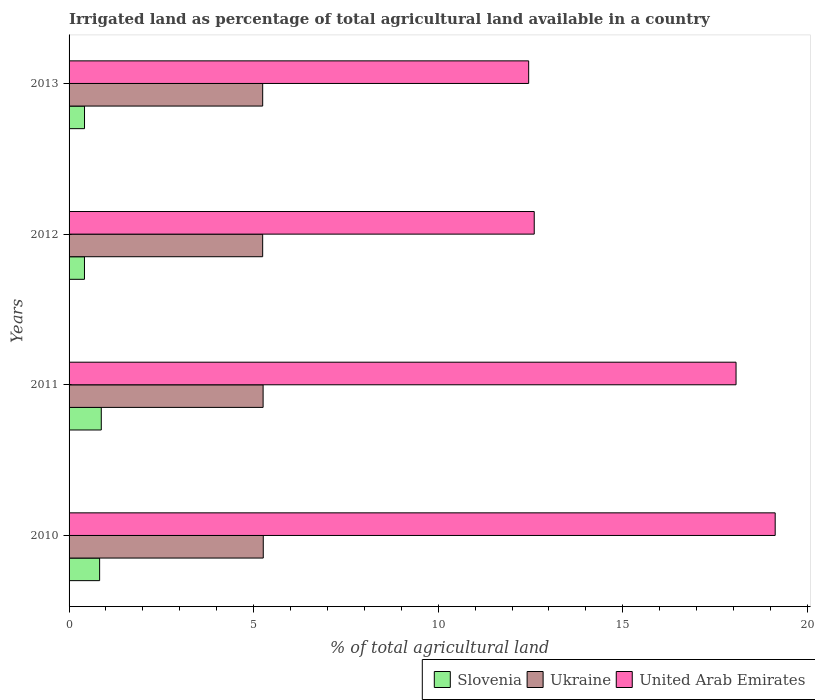How many groups of bars are there?
Keep it short and to the point. 4. Are the number of bars per tick equal to the number of legend labels?
Make the answer very short. Yes. Are the number of bars on each tick of the Y-axis equal?
Offer a terse response. Yes. What is the percentage of irrigated land in Ukraine in 2013?
Ensure brevity in your answer.  5.25. Across all years, what is the maximum percentage of irrigated land in United Arab Emirates?
Give a very brief answer. 19.13. Across all years, what is the minimum percentage of irrigated land in United Arab Emirates?
Your response must be concise. 12.45. In which year was the percentage of irrigated land in Slovenia maximum?
Provide a succinct answer. 2011. In which year was the percentage of irrigated land in Ukraine minimum?
Your answer should be very brief. 2012. What is the total percentage of irrigated land in United Arab Emirates in the graph?
Your response must be concise. 62.25. What is the difference between the percentage of irrigated land in Ukraine in 2010 and that in 2011?
Your response must be concise. 0. What is the difference between the percentage of irrigated land in United Arab Emirates in 2010 and the percentage of irrigated land in Slovenia in 2011?
Your answer should be very brief. 18.26. What is the average percentage of irrigated land in United Arab Emirates per year?
Your response must be concise. 15.56. In the year 2012, what is the difference between the percentage of irrigated land in United Arab Emirates and percentage of irrigated land in Ukraine?
Offer a terse response. 7.36. In how many years, is the percentage of irrigated land in Slovenia greater than 9 %?
Your answer should be very brief. 0. What is the ratio of the percentage of irrigated land in Ukraine in 2010 to that in 2013?
Offer a terse response. 1. Is the percentage of irrigated land in Slovenia in 2012 less than that in 2013?
Keep it short and to the point. Yes. Is the difference between the percentage of irrigated land in United Arab Emirates in 2010 and 2011 greater than the difference between the percentage of irrigated land in Ukraine in 2010 and 2011?
Your response must be concise. Yes. What is the difference between the highest and the second highest percentage of irrigated land in United Arab Emirates?
Provide a short and direct response. 1.06. What is the difference between the highest and the lowest percentage of irrigated land in United Arab Emirates?
Offer a terse response. 6.68. What does the 3rd bar from the top in 2013 represents?
Your response must be concise. Slovenia. What does the 2nd bar from the bottom in 2013 represents?
Offer a terse response. Ukraine. Is it the case that in every year, the sum of the percentage of irrigated land in United Arab Emirates and percentage of irrigated land in Ukraine is greater than the percentage of irrigated land in Slovenia?
Your answer should be very brief. Yes. How many bars are there?
Provide a succinct answer. 12. Are all the bars in the graph horizontal?
Give a very brief answer. Yes. How many years are there in the graph?
Offer a very short reply. 4. Does the graph contain any zero values?
Offer a terse response. No. How are the legend labels stacked?
Offer a terse response. Horizontal. What is the title of the graph?
Your answer should be compact. Irrigated land as percentage of total agricultural land available in a country. Does "Bosnia and Herzegovina" appear as one of the legend labels in the graph?
Keep it short and to the point. No. What is the label or title of the X-axis?
Make the answer very short. % of total agricultural land. What is the % of total agricultural land in Slovenia in 2010?
Offer a very short reply. 0.83. What is the % of total agricultural land in Ukraine in 2010?
Make the answer very short. 5.26. What is the % of total agricultural land in United Arab Emirates in 2010?
Offer a very short reply. 19.13. What is the % of total agricultural land of Slovenia in 2011?
Make the answer very short. 0.87. What is the % of total agricultural land of Ukraine in 2011?
Offer a terse response. 5.26. What is the % of total agricultural land of United Arab Emirates in 2011?
Your answer should be very brief. 18.07. What is the % of total agricultural land in Slovenia in 2012?
Make the answer very short. 0.42. What is the % of total agricultural land of Ukraine in 2012?
Keep it short and to the point. 5.24. What is the % of total agricultural land of United Arab Emirates in 2012?
Keep it short and to the point. 12.6. What is the % of total agricultural land of Slovenia in 2013?
Make the answer very short. 0.42. What is the % of total agricultural land in Ukraine in 2013?
Your response must be concise. 5.25. What is the % of total agricultural land of United Arab Emirates in 2013?
Your answer should be very brief. 12.45. Across all years, what is the maximum % of total agricultural land of Slovenia?
Ensure brevity in your answer.  0.87. Across all years, what is the maximum % of total agricultural land of Ukraine?
Offer a terse response. 5.26. Across all years, what is the maximum % of total agricultural land in United Arab Emirates?
Give a very brief answer. 19.13. Across all years, what is the minimum % of total agricultural land in Slovenia?
Your response must be concise. 0.42. Across all years, what is the minimum % of total agricultural land in Ukraine?
Provide a succinct answer. 5.24. Across all years, what is the minimum % of total agricultural land of United Arab Emirates?
Offer a very short reply. 12.45. What is the total % of total agricultural land in Slovenia in the graph?
Ensure brevity in your answer.  2.54. What is the total % of total agricultural land of Ukraine in the graph?
Keep it short and to the point. 21.01. What is the total % of total agricultural land in United Arab Emirates in the graph?
Provide a succinct answer. 62.25. What is the difference between the % of total agricultural land of Slovenia in 2010 and that in 2011?
Make the answer very short. -0.04. What is the difference between the % of total agricultural land in Ukraine in 2010 and that in 2011?
Offer a very short reply. 0. What is the difference between the % of total agricultural land in United Arab Emirates in 2010 and that in 2011?
Offer a very short reply. 1.06. What is the difference between the % of total agricultural land in Slovenia in 2010 and that in 2012?
Offer a very short reply. 0.41. What is the difference between the % of total agricultural land of Ukraine in 2010 and that in 2012?
Your answer should be compact. 0.02. What is the difference between the % of total agricultural land of United Arab Emirates in 2010 and that in 2012?
Provide a succinct answer. 6.53. What is the difference between the % of total agricultural land in Slovenia in 2010 and that in 2013?
Offer a terse response. 0.41. What is the difference between the % of total agricultural land in Ukraine in 2010 and that in 2013?
Ensure brevity in your answer.  0.02. What is the difference between the % of total agricultural land in United Arab Emirates in 2010 and that in 2013?
Ensure brevity in your answer.  6.68. What is the difference between the % of total agricultural land of Slovenia in 2011 and that in 2012?
Your answer should be very brief. 0.46. What is the difference between the % of total agricultural land in Ukraine in 2011 and that in 2012?
Offer a terse response. 0.01. What is the difference between the % of total agricultural land of United Arab Emirates in 2011 and that in 2012?
Offer a very short reply. 5.47. What is the difference between the % of total agricultural land in Slovenia in 2011 and that in 2013?
Your answer should be very brief. 0.45. What is the difference between the % of total agricultural land in Ukraine in 2011 and that in 2013?
Give a very brief answer. 0.01. What is the difference between the % of total agricultural land of United Arab Emirates in 2011 and that in 2013?
Keep it short and to the point. 5.62. What is the difference between the % of total agricultural land in Slovenia in 2012 and that in 2013?
Keep it short and to the point. -0. What is the difference between the % of total agricultural land in Ukraine in 2012 and that in 2013?
Keep it short and to the point. -0. What is the difference between the % of total agricultural land of United Arab Emirates in 2012 and that in 2013?
Ensure brevity in your answer.  0.15. What is the difference between the % of total agricultural land in Slovenia in 2010 and the % of total agricultural land in Ukraine in 2011?
Offer a terse response. -4.43. What is the difference between the % of total agricultural land of Slovenia in 2010 and the % of total agricultural land of United Arab Emirates in 2011?
Your answer should be compact. -17.24. What is the difference between the % of total agricultural land in Ukraine in 2010 and the % of total agricultural land in United Arab Emirates in 2011?
Make the answer very short. -12.81. What is the difference between the % of total agricultural land in Slovenia in 2010 and the % of total agricultural land in Ukraine in 2012?
Make the answer very short. -4.42. What is the difference between the % of total agricultural land in Slovenia in 2010 and the % of total agricultural land in United Arab Emirates in 2012?
Your answer should be very brief. -11.77. What is the difference between the % of total agricultural land of Ukraine in 2010 and the % of total agricultural land of United Arab Emirates in 2012?
Ensure brevity in your answer.  -7.34. What is the difference between the % of total agricultural land of Slovenia in 2010 and the % of total agricultural land of Ukraine in 2013?
Your response must be concise. -4.42. What is the difference between the % of total agricultural land of Slovenia in 2010 and the % of total agricultural land of United Arab Emirates in 2013?
Offer a terse response. -11.62. What is the difference between the % of total agricultural land in Ukraine in 2010 and the % of total agricultural land in United Arab Emirates in 2013?
Ensure brevity in your answer.  -7.19. What is the difference between the % of total agricultural land in Slovenia in 2011 and the % of total agricultural land in Ukraine in 2012?
Your answer should be very brief. -4.37. What is the difference between the % of total agricultural land of Slovenia in 2011 and the % of total agricultural land of United Arab Emirates in 2012?
Provide a succinct answer. -11.73. What is the difference between the % of total agricultural land of Ukraine in 2011 and the % of total agricultural land of United Arab Emirates in 2012?
Your response must be concise. -7.34. What is the difference between the % of total agricultural land of Slovenia in 2011 and the % of total agricultural land of Ukraine in 2013?
Your response must be concise. -4.37. What is the difference between the % of total agricultural land of Slovenia in 2011 and the % of total agricultural land of United Arab Emirates in 2013?
Make the answer very short. -11.58. What is the difference between the % of total agricultural land in Ukraine in 2011 and the % of total agricultural land in United Arab Emirates in 2013?
Your answer should be very brief. -7.19. What is the difference between the % of total agricultural land in Slovenia in 2012 and the % of total agricultural land in Ukraine in 2013?
Offer a very short reply. -4.83. What is the difference between the % of total agricultural land in Slovenia in 2012 and the % of total agricultural land in United Arab Emirates in 2013?
Make the answer very short. -12.03. What is the difference between the % of total agricultural land of Ukraine in 2012 and the % of total agricultural land of United Arab Emirates in 2013?
Your answer should be compact. -7.21. What is the average % of total agricultural land in Slovenia per year?
Provide a succinct answer. 0.63. What is the average % of total agricultural land in Ukraine per year?
Your answer should be very brief. 5.25. What is the average % of total agricultural land of United Arab Emirates per year?
Ensure brevity in your answer.  15.56. In the year 2010, what is the difference between the % of total agricultural land of Slovenia and % of total agricultural land of Ukraine?
Keep it short and to the point. -4.43. In the year 2010, what is the difference between the % of total agricultural land in Slovenia and % of total agricultural land in United Arab Emirates?
Make the answer very short. -18.3. In the year 2010, what is the difference between the % of total agricultural land in Ukraine and % of total agricultural land in United Arab Emirates?
Your answer should be compact. -13.87. In the year 2011, what is the difference between the % of total agricultural land of Slovenia and % of total agricultural land of Ukraine?
Ensure brevity in your answer.  -4.38. In the year 2011, what is the difference between the % of total agricultural land of Slovenia and % of total agricultural land of United Arab Emirates?
Offer a very short reply. -17.2. In the year 2011, what is the difference between the % of total agricultural land of Ukraine and % of total agricultural land of United Arab Emirates?
Your answer should be very brief. -12.81. In the year 2012, what is the difference between the % of total agricultural land of Slovenia and % of total agricultural land of Ukraine?
Your response must be concise. -4.83. In the year 2012, what is the difference between the % of total agricultural land in Slovenia and % of total agricultural land in United Arab Emirates?
Offer a terse response. -12.18. In the year 2012, what is the difference between the % of total agricultural land in Ukraine and % of total agricultural land in United Arab Emirates?
Provide a succinct answer. -7.36. In the year 2013, what is the difference between the % of total agricultural land in Slovenia and % of total agricultural land in Ukraine?
Offer a very short reply. -4.83. In the year 2013, what is the difference between the % of total agricultural land in Slovenia and % of total agricultural land in United Arab Emirates?
Your response must be concise. -12.03. In the year 2013, what is the difference between the % of total agricultural land in Ukraine and % of total agricultural land in United Arab Emirates?
Make the answer very short. -7.21. What is the ratio of the % of total agricultural land in Slovenia in 2010 to that in 2011?
Your answer should be compact. 0.95. What is the ratio of the % of total agricultural land of Ukraine in 2010 to that in 2011?
Make the answer very short. 1. What is the ratio of the % of total agricultural land of United Arab Emirates in 2010 to that in 2011?
Keep it short and to the point. 1.06. What is the ratio of the % of total agricultural land in Slovenia in 2010 to that in 2012?
Ensure brevity in your answer.  1.99. What is the ratio of the % of total agricultural land of Ukraine in 2010 to that in 2012?
Give a very brief answer. 1. What is the ratio of the % of total agricultural land of United Arab Emirates in 2010 to that in 2012?
Keep it short and to the point. 1.52. What is the ratio of the % of total agricultural land in Slovenia in 2010 to that in 2013?
Keep it short and to the point. 1.98. What is the ratio of the % of total agricultural land in Ukraine in 2010 to that in 2013?
Give a very brief answer. 1. What is the ratio of the % of total agricultural land in United Arab Emirates in 2010 to that in 2013?
Your response must be concise. 1.54. What is the ratio of the % of total agricultural land in Slovenia in 2011 to that in 2012?
Your answer should be very brief. 2.09. What is the ratio of the % of total agricultural land in Ukraine in 2011 to that in 2012?
Give a very brief answer. 1. What is the ratio of the % of total agricultural land in United Arab Emirates in 2011 to that in 2012?
Ensure brevity in your answer.  1.43. What is the ratio of the % of total agricultural land in Slovenia in 2011 to that in 2013?
Offer a terse response. 2.09. What is the ratio of the % of total agricultural land in Ukraine in 2011 to that in 2013?
Provide a succinct answer. 1. What is the ratio of the % of total agricultural land in United Arab Emirates in 2011 to that in 2013?
Your response must be concise. 1.45. What is the ratio of the % of total agricultural land in Slovenia in 2012 to that in 2013?
Offer a very short reply. 1. What is the ratio of the % of total agricultural land in Ukraine in 2012 to that in 2013?
Keep it short and to the point. 1. What is the ratio of the % of total agricultural land in United Arab Emirates in 2012 to that in 2013?
Give a very brief answer. 1.01. What is the difference between the highest and the second highest % of total agricultural land of Slovenia?
Provide a short and direct response. 0.04. What is the difference between the highest and the second highest % of total agricultural land of Ukraine?
Make the answer very short. 0. What is the difference between the highest and the second highest % of total agricultural land of United Arab Emirates?
Provide a succinct answer. 1.06. What is the difference between the highest and the lowest % of total agricultural land in Slovenia?
Offer a terse response. 0.46. What is the difference between the highest and the lowest % of total agricultural land of Ukraine?
Your response must be concise. 0.02. What is the difference between the highest and the lowest % of total agricultural land of United Arab Emirates?
Your response must be concise. 6.68. 